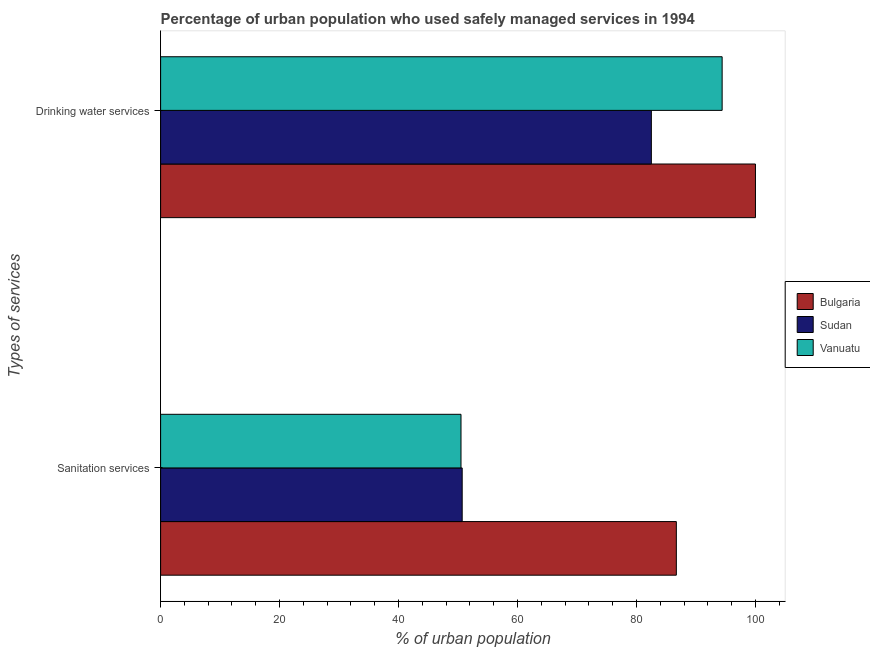How many different coloured bars are there?
Your answer should be compact. 3. How many groups of bars are there?
Make the answer very short. 2. Are the number of bars per tick equal to the number of legend labels?
Offer a very short reply. Yes. Are the number of bars on each tick of the Y-axis equal?
Give a very brief answer. Yes. How many bars are there on the 1st tick from the top?
Offer a very short reply. 3. How many bars are there on the 2nd tick from the bottom?
Make the answer very short. 3. What is the label of the 1st group of bars from the top?
Offer a very short reply. Drinking water services. What is the percentage of urban population who used sanitation services in Vanuatu?
Ensure brevity in your answer.  50.5. Across all countries, what is the maximum percentage of urban population who used sanitation services?
Keep it short and to the point. 86.7. Across all countries, what is the minimum percentage of urban population who used drinking water services?
Offer a very short reply. 82.5. In which country was the percentage of urban population who used drinking water services minimum?
Your answer should be compact. Sudan. What is the total percentage of urban population who used drinking water services in the graph?
Give a very brief answer. 276.9. What is the difference between the percentage of urban population who used drinking water services in Vanuatu and that in Sudan?
Offer a terse response. 11.9. What is the difference between the percentage of urban population who used sanitation services in Sudan and the percentage of urban population who used drinking water services in Vanuatu?
Offer a terse response. -43.7. What is the average percentage of urban population who used sanitation services per country?
Provide a short and direct response. 62.63. What is the difference between the percentage of urban population who used sanitation services and percentage of urban population who used drinking water services in Sudan?
Offer a terse response. -31.8. In how many countries, is the percentage of urban population who used drinking water services greater than 64 %?
Your response must be concise. 3. What is the ratio of the percentage of urban population who used drinking water services in Vanuatu to that in Sudan?
Offer a very short reply. 1.14. What does the 1st bar from the top in Drinking water services represents?
Keep it short and to the point. Vanuatu. What does the 1st bar from the bottom in Drinking water services represents?
Offer a very short reply. Bulgaria. How many countries are there in the graph?
Provide a short and direct response. 3. What is the difference between two consecutive major ticks on the X-axis?
Ensure brevity in your answer.  20. Are the values on the major ticks of X-axis written in scientific E-notation?
Provide a succinct answer. No. Does the graph contain grids?
Provide a short and direct response. No. Where does the legend appear in the graph?
Ensure brevity in your answer.  Center right. What is the title of the graph?
Your answer should be very brief. Percentage of urban population who used safely managed services in 1994. Does "Vietnam" appear as one of the legend labels in the graph?
Your response must be concise. No. What is the label or title of the X-axis?
Your response must be concise. % of urban population. What is the label or title of the Y-axis?
Your answer should be compact. Types of services. What is the % of urban population of Bulgaria in Sanitation services?
Offer a terse response. 86.7. What is the % of urban population of Sudan in Sanitation services?
Ensure brevity in your answer.  50.7. What is the % of urban population of Vanuatu in Sanitation services?
Your response must be concise. 50.5. What is the % of urban population in Sudan in Drinking water services?
Give a very brief answer. 82.5. What is the % of urban population in Vanuatu in Drinking water services?
Offer a terse response. 94.4. Across all Types of services, what is the maximum % of urban population of Sudan?
Your answer should be very brief. 82.5. Across all Types of services, what is the maximum % of urban population in Vanuatu?
Give a very brief answer. 94.4. Across all Types of services, what is the minimum % of urban population in Bulgaria?
Your answer should be very brief. 86.7. Across all Types of services, what is the minimum % of urban population of Sudan?
Ensure brevity in your answer.  50.7. Across all Types of services, what is the minimum % of urban population in Vanuatu?
Offer a very short reply. 50.5. What is the total % of urban population in Bulgaria in the graph?
Ensure brevity in your answer.  186.7. What is the total % of urban population of Sudan in the graph?
Provide a succinct answer. 133.2. What is the total % of urban population in Vanuatu in the graph?
Provide a short and direct response. 144.9. What is the difference between the % of urban population of Sudan in Sanitation services and that in Drinking water services?
Give a very brief answer. -31.8. What is the difference between the % of urban population in Vanuatu in Sanitation services and that in Drinking water services?
Your answer should be very brief. -43.9. What is the difference between the % of urban population in Bulgaria in Sanitation services and the % of urban population in Sudan in Drinking water services?
Your answer should be very brief. 4.2. What is the difference between the % of urban population in Sudan in Sanitation services and the % of urban population in Vanuatu in Drinking water services?
Provide a succinct answer. -43.7. What is the average % of urban population in Bulgaria per Types of services?
Make the answer very short. 93.35. What is the average % of urban population in Sudan per Types of services?
Your answer should be compact. 66.6. What is the average % of urban population of Vanuatu per Types of services?
Offer a terse response. 72.45. What is the difference between the % of urban population in Bulgaria and % of urban population in Sudan in Sanitation services?
Your answer should be compact. 36. What is the difference between the % of urban population in Bulgaria and % of urban population in Vanuatu in Sanitation services?
Keep it short and to the point. 36.2. What is the difference between the % of urban population of Sudan and % of urban population of Vanuatu in Sanitation services?
Offer a very short reply. 0.2. What is the difference between the % of urban population in Sudan and % of urban population in Vanuatu in Drinking water services?
Offer a terse response. -11.9. What is the ratio of the % of urban population of Bulgaria in Sanitation services to that in Drinking water services?
Give a very brief answer. 0.87. What is the ratio of the % of urban population of Sudan in Sanitation services to that in Drinking water services?
Your response must be concise. 0.61. What is the ratio of the % of urban population of Vanuatu in Sanitation services to that in Drinking water services?
Make the answer very short. 0.54. What is the difference between the highest and the second highest % of urban population in Sudan?
Keep it short and to the point. 31.8. What is the difference between the highest and the second highest % of urban population in Vanuatu?
Offer a very short reply. 43.9. What is the difference between the highest and the lowest % of urban population of Sudan?
Keep it short and to the point. 31.8. What is the difference between the highest and the lowest % of urban population of Vanuatu?
Ensure brevity in your answer.  43.9. 